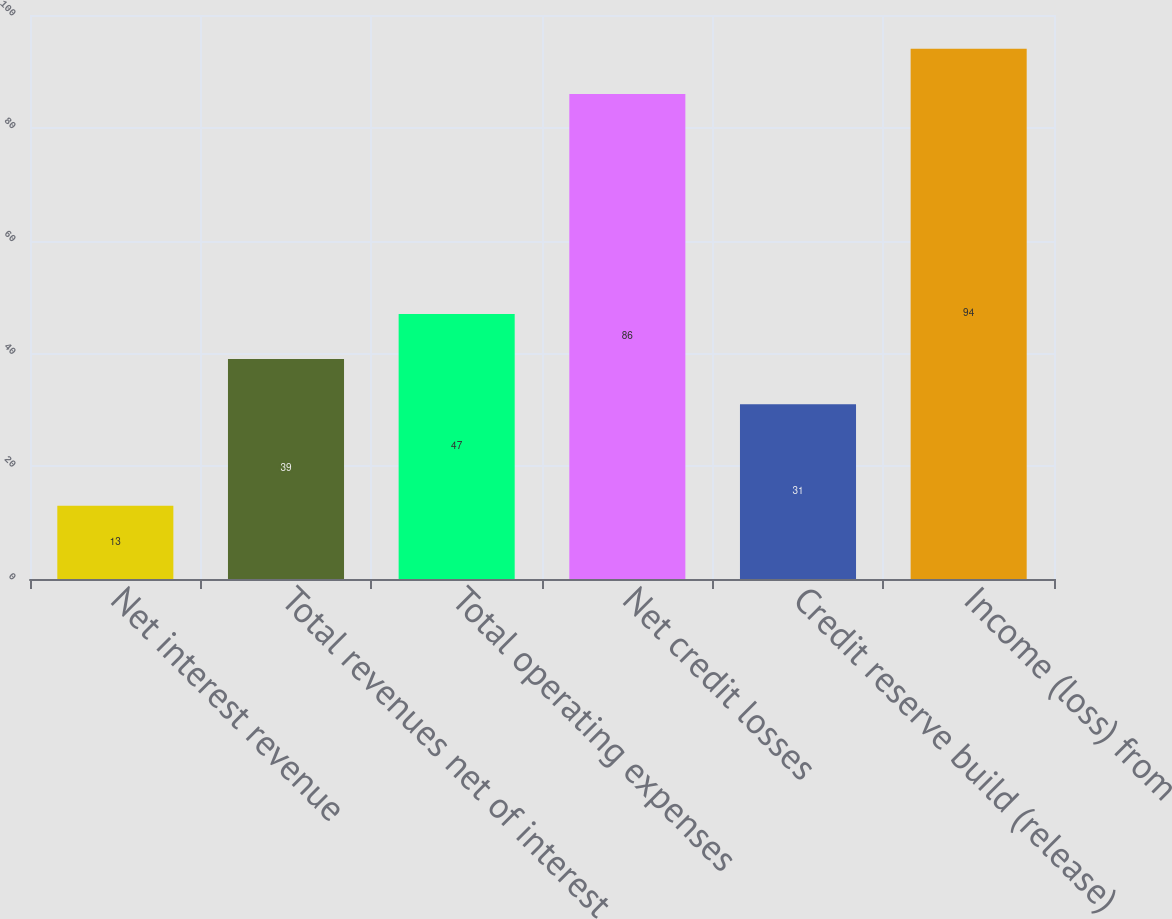Convert chart to OTSL. <chart><loc_0><loc_0><loc_500><loc_500><bar_chart><fcel>Net interest revenue<fcel>Total revenues net of interest<fcel>Total operating expenses<fcel>Net credit losses<fcel>Credit reserve build (release)<fcel>Income (loss) from<nl><fcel>13<fcel>39<fcel>47<fcel>86<fcel>31<fcel>94<nl></chart> 